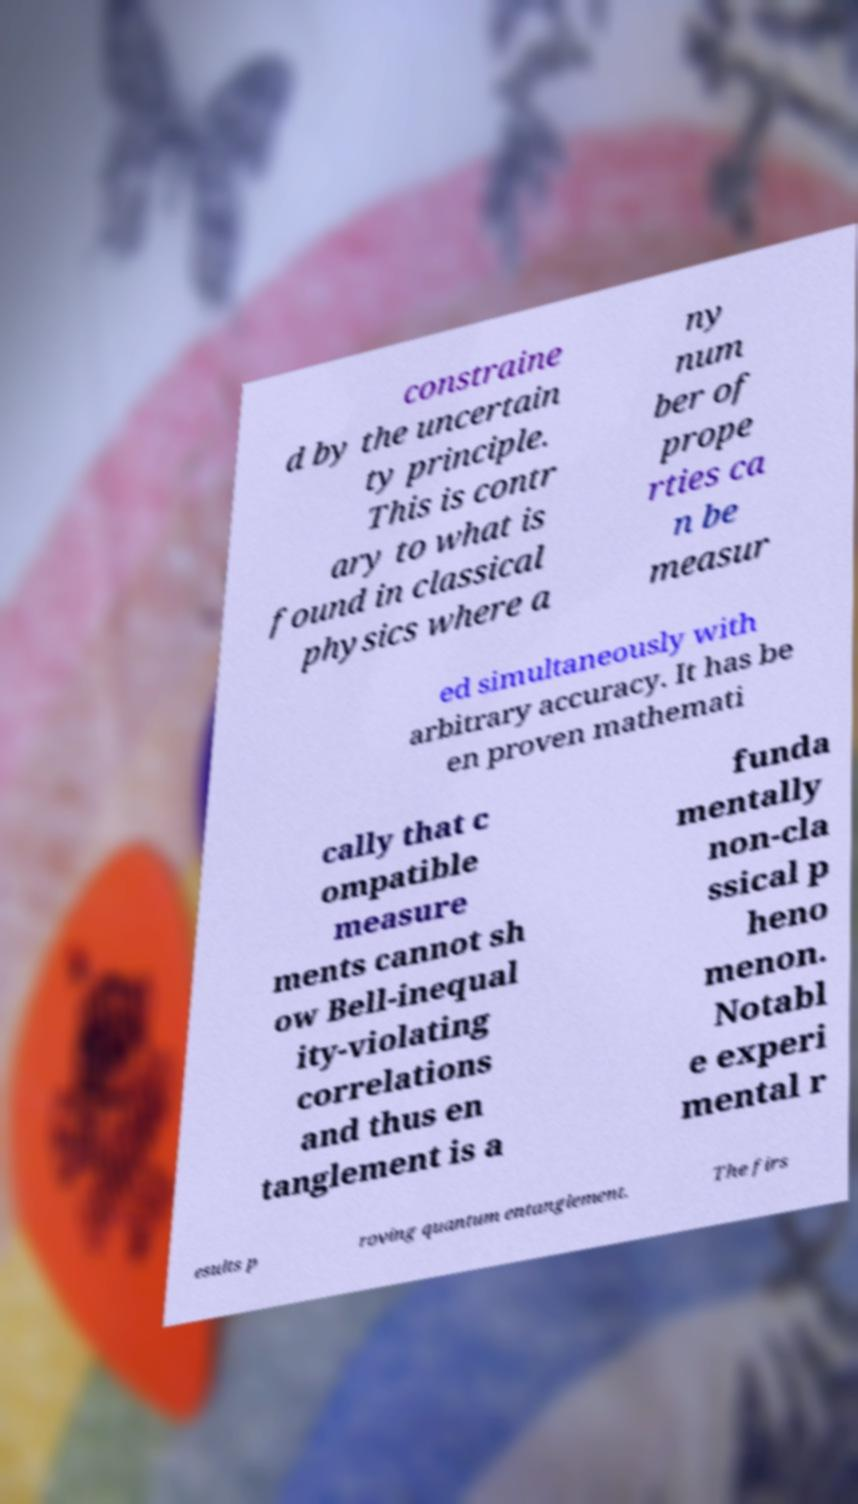Could you extract and type out the text from this image? constraine d by the uncertain ty principle. This is contr ary to what is found in classical physics where a ny num ber of prope rties ca n be measur ed simultaneously with arbitrary accuracy. It has be en proven mathemati cally that c ompatible measure ments cannot sh ow Bell-inequal ity-violating correlations and thus en tanglement is a funda mentally non-cla ssical p heno menon. Notabl e experi mental r esults p roving quantum entanglement. The firs 